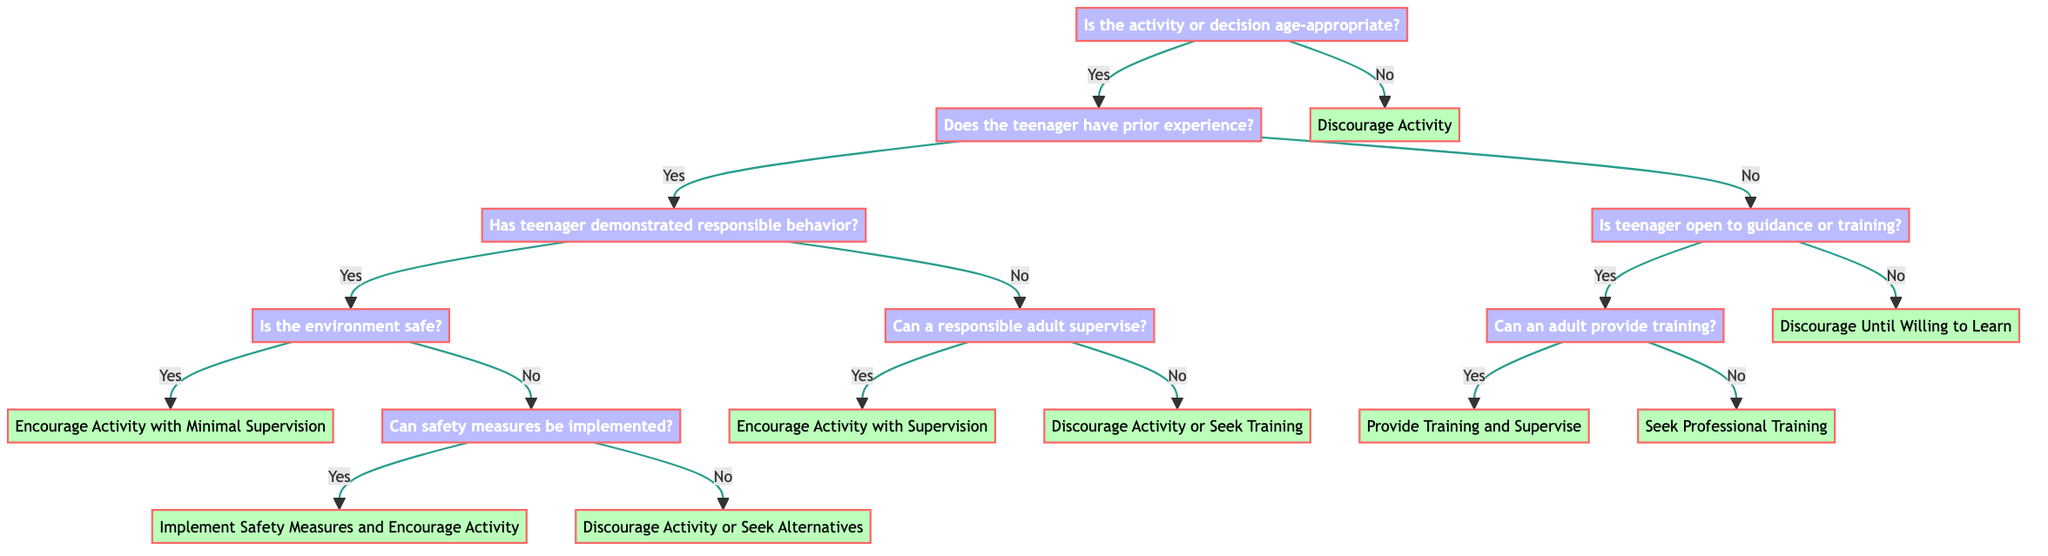Is the first decision node related to age appropriateness? Yes, the first decision node in the diagram asks if the activity or decision is age-appropriate, making it the starting point for assessing the situation.
Answer: Yes What happens if the teenager does not have prior experience? If the teenager does not have prior experience, the flow leads to assessing if the teenager is open to guidance or training, which has its own branch of outcomes.
Answer: Assess openness to guidance What is the outcome if the teenager has experience and demonstrated responsible behavior but the environment is unsafe? In this case, the flow leads to examining if safety measures can be implemented. If yes, the recommendation is to implement safety measures and encourage the activity; if no, the recommendation is to discourage the activity or seek alternatives.
Answer: Implement safety measures and encourage activity or discourage activity How many total outcomes are there in the diagram? There are a total of six distinct outcomes presented in the decision tree after going through all potential paths.
Answer: Six What does the diagram suggest if the activity is not age-appropriate? The diagram clearly states that if the activity is not age-appropriate, the advice is to discourage the activity altogether, ending that branch of the decision-making process.
Answer: Discourage activity What sequential steps are suggested if the teenager is open to guidance or training? If the teenager is open to guidance or training, the next step is to check if a responsible adult can provide training. If yes, the recommendation is to provide training and supervise until experience is gained; if no, the advice is to seek professional training opportunities.
Answer: Provide training and supervise or seek professional training What does the diagram indicate about the relationship between experience and supervision? The diagram indicates that if the teenager has no prior experience, it checks for the possibility of supervision by a responsible adult. This highlights a conditional relationship: lack of experience leads to checking for supervision options.
Answer: Check for supervision options If safety measures cannot be implemented, what is the recommendation? The recommendation, if safety measures cannot be implemented, is to discourage the activity or seek alternatives, indicating a clear cutoff for safety concerns despite other factors being positive.
Answer: Discourage activity or seek alternatives 